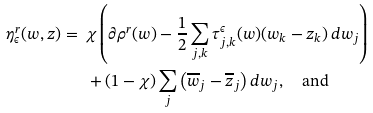<formula> <loc_0><loc_0><loc_500><loc_500>\eta ^ { r } _ { \epsilon } ( w , z ) = \ & \chi \left ( \partial \rho ^ { r } ( w ) - \frac { 1 } { 2 } \sum _ { j , k } \tau ^ { \epsilon } _ { j , k } ( w ) ( w _ { k } - z _ { k } ) \, d w _ { j } \right ) \\ & + ( 1 - \chi ) \sum _ { j } \left ( \overline { w } _ { j } - \overline { z } _ { j } \right ) d w _ { j } , \quad \text {and}</formula> 